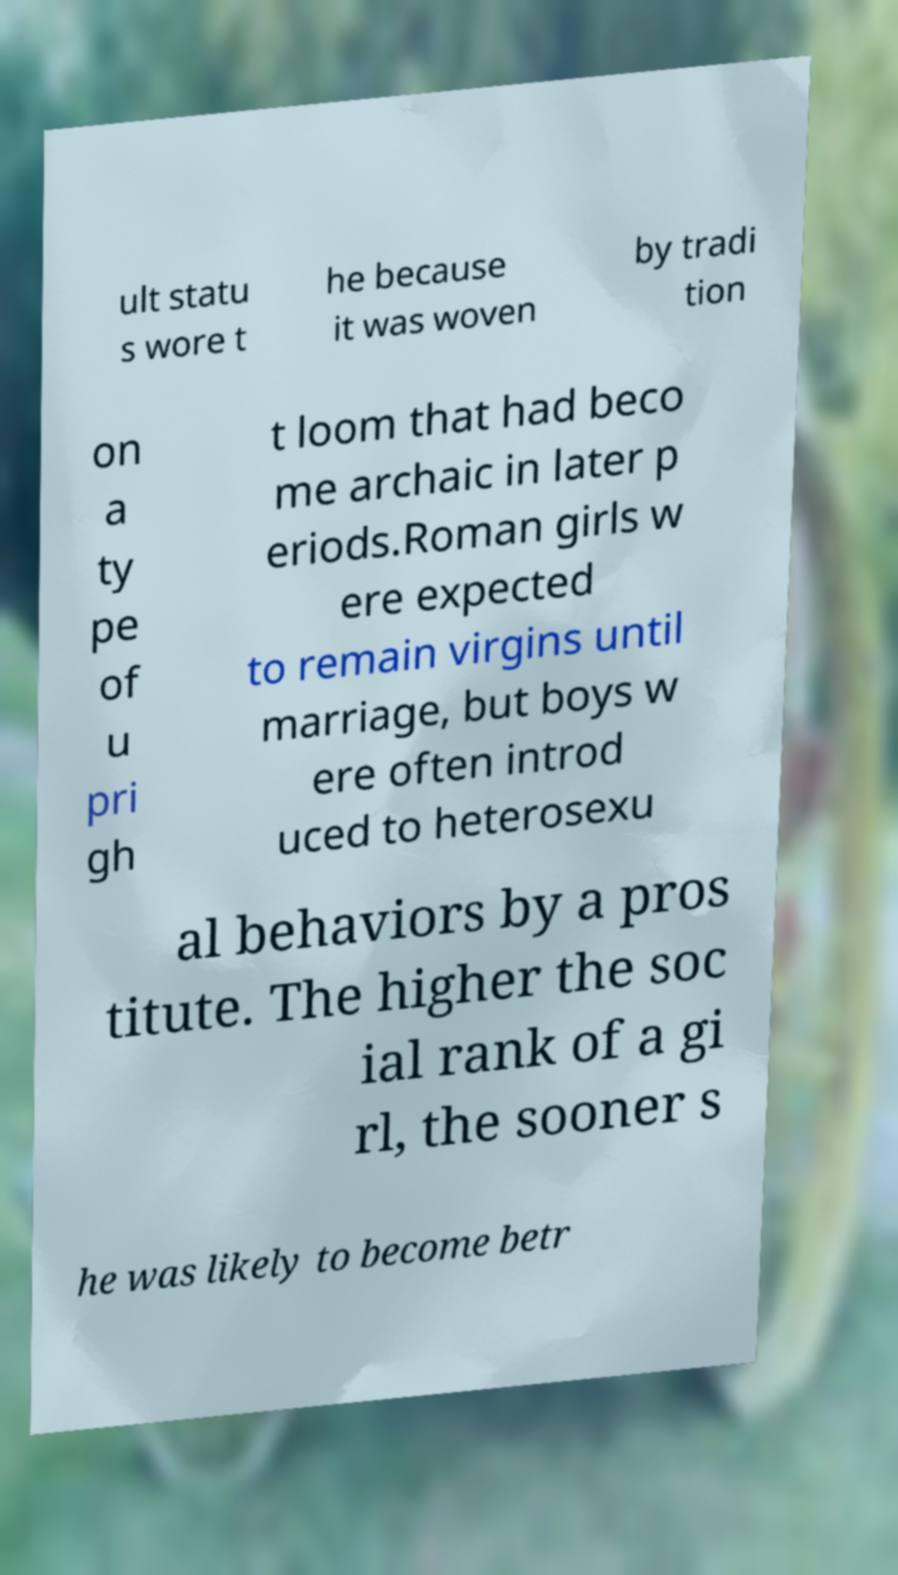Can you accurately transcribe the text from the provided image for me? ult statu s wore t he because it was woven by tradi tion on a ty pe of u pri gh t loom that had beco me archaic in later p eriods.Roman girls w ere expected to remain virgins until marriage, but boys w ere often introd uced to heterosexu al behaviors by a pros titute. The higher the soc ial rank of a gi rl, the sooner s he was likely to become betr 